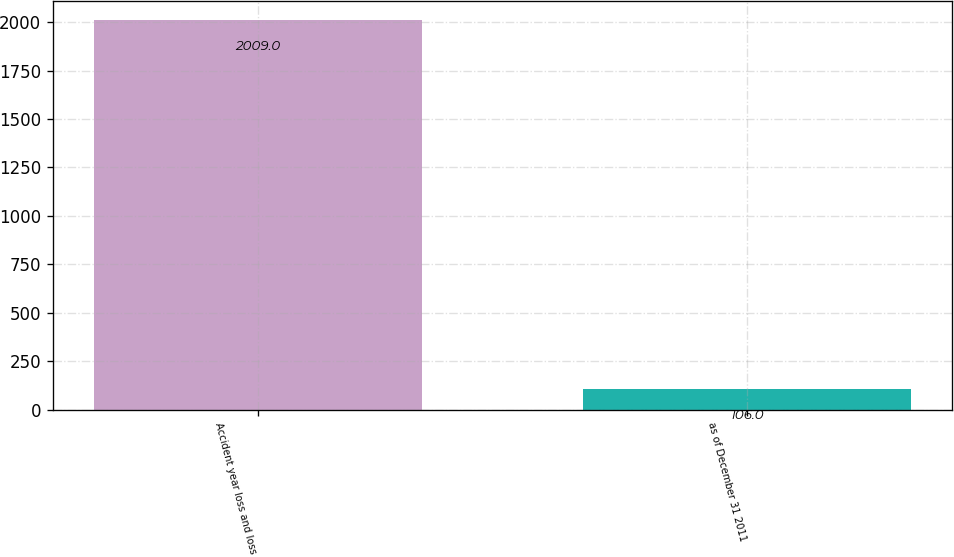Convert chart to OTSL. <chart><loc_0><loc_0><loc_500><loc_500><bar_chart><fcel>Accident year loss and loss<fcel>as of December 31 2011<nl><fcel>2009<fcel>106<nl></chart> 